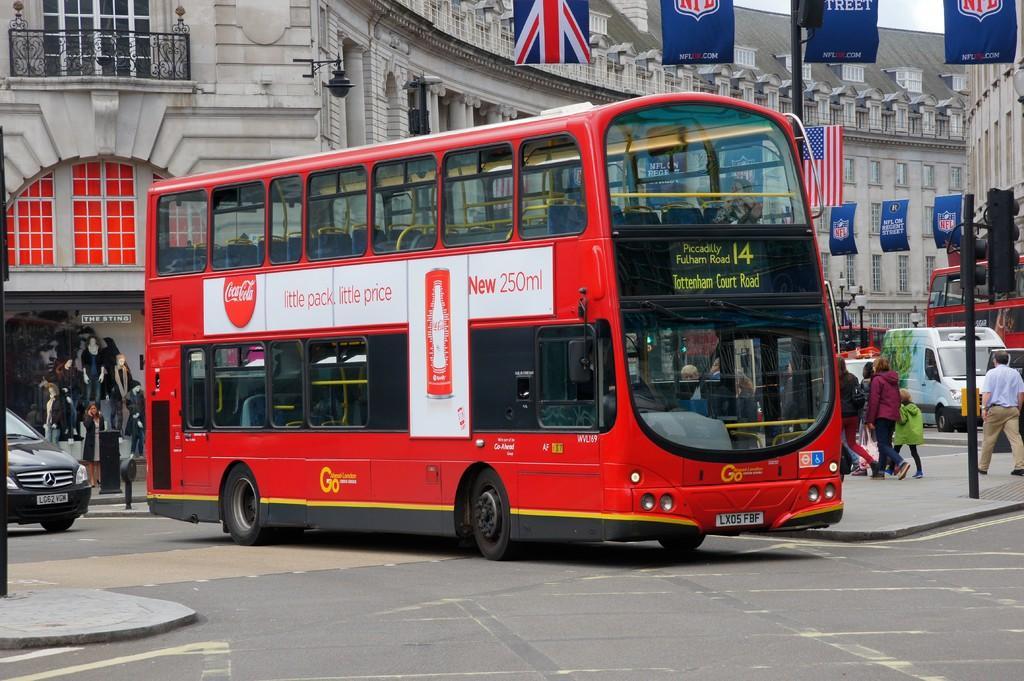Please provide a concise description of this image. In this picture there is a red color double Decker bus moving on the road. Behind there is a car and cloth shop. In the background there is a white color building and some flags. 